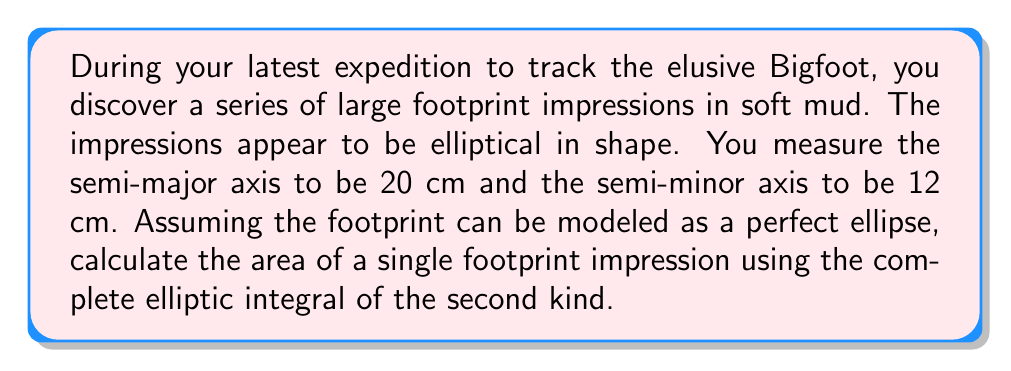Solve this math problem. To solve this problem, we'll use the formula for the area of an ellipse using the complete elliptic integral of the second kind. The steps are as follows:

1) The area of an ellipse is given by:

   $$A = \pi ab$$

   where $a$ is the semi-major axis and $b$ is the semi-minor axis.

2) However, we can express this more precisely using the complete elliptic integral of the second kind, $E(e)$:

   $$A = \pi b^2 + \pi a(a-b)E(e)$$

   where $e$ is the eccentricity of the ellipse.

3) The eccentricity $e$ is calculated as:

   $$e = \sqrt{1 - \frac{b^2}{a^2}}$$

4) Let's calculate $e$:

   $$e = \sqrt{1 - \frac{12^2}{20^2}} = \sqrt{1 - \frac{144}{400}} = \sqrt{\frac{256}{400}} = \frac{16}{20} = 0.8$$

5) Now we need to evaluate $E(0.8)$. This is typically done numerically or looked up in tables. The value is approximately 1.2110.

6) Now we can plug everything into our area formula:

   $$A = \pi (12)^2 + \pi (20)(20-12)E(0.8)$$
   $$A = 144\pi + 160\pi(1.2110)$$
   $$A = 144\pi + 193.76\pi$$
   $$A = 337.76\pi$$

7) Evaluating this:

   $$A \approx 1060.95 \text{ cm}^2$$

Therefore, the area of a single Bigfoot footprint impression is approximately 1060.95 square centimeters.
Answer: The area of the footprint impression is approximately 1060.95 cm². 